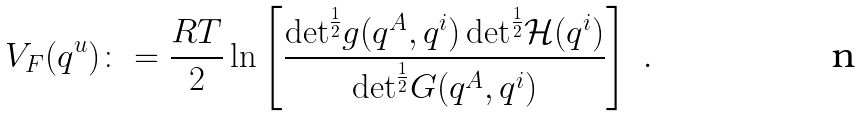Convert formula to latex. <formula><loc_0><loc_0><loc_500><loc_500>V _ { F } ( q ^ { u } ) \colon = \frac { R T } { 2 } \ln \left [ \frac { { \det } ^ { \frac { 1 } { 2 } } g ( q ^ { A } , q ^ { i } ) \, { \det } ^ { \frac { 1 } { 2 } } \mathcal { H } ( q ^ { i } ) } { { \det } ^ { \frac { 1 } { 2 } } G ( q ^ { A } , q ^ { i } ) } \right ] \ .</formula> 